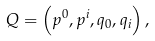Convert formula to latex. <formula><loc_0><loc_0><loc_500><loc_500>Q = \left ( p ^ { 0 } , p ^ { i } , q _ { 0 } , q _ { i } \right ) ,</formula> 